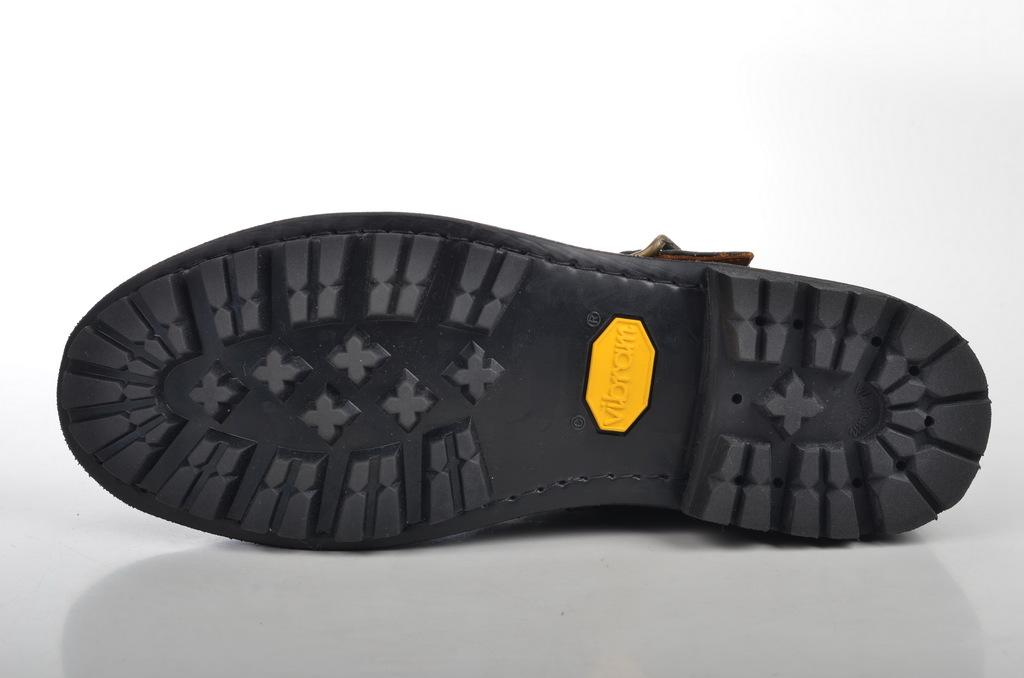What is the main subject of the image? The main subject of the image is the back side of a pair of shoes. Can you describe any specific features of the shoes? Unfortunately, the image only shows the back side of the shoes, so it is difficult to describe any specific features. What might be the purpose of the shoes? The purpose of the shoes could be for walking, running, or other activities, but this cannot be determined from the image alone. What type of throne is visible in the image? There is no throne present in the image; it only shows the back side of a pair of shoes. How does the gate open in the image? There is no gate present in the image; it only shows the back side of a pair of shoes. 